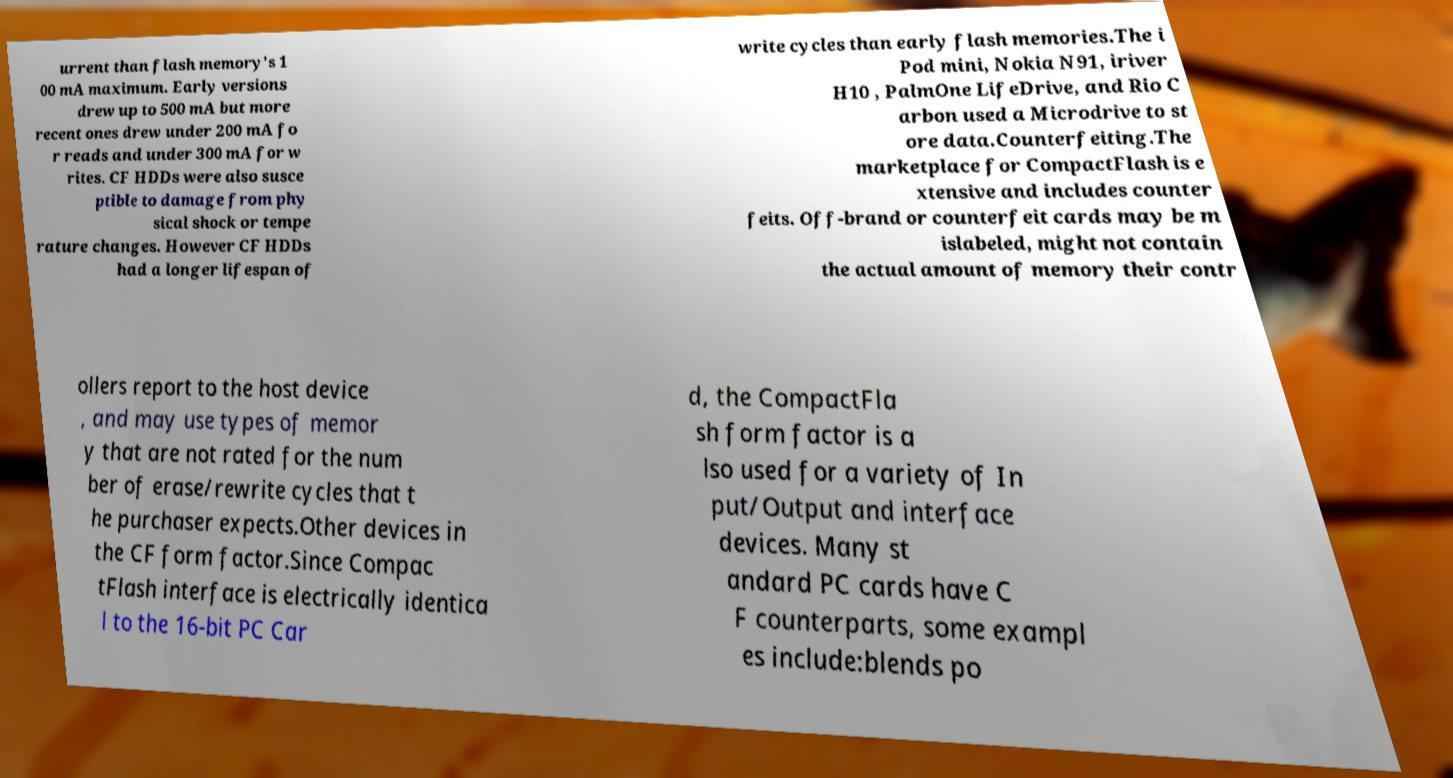Please identify and transcribe the text found in this image. urrent than flash memory's 1 00 mA maximum. Early versions drew up to 500 mA but more recent ones drew under 200 mA fo r reads and under 300 mA for w rites. CF HDDs were also susce ptible to damage from phy sical shock or tempe rature changes. However CF HDDs had a longer lifespan of write cycles than early flash memories.The i Pod mini, Nokia N91, iriver H10 , PalmOne LifeDrive, and Rio C arbon used a Microdrive to st ore data.Counterfeiting.The marketplace for CompactFlash is e xtensive and includes counter feits. Off-brand or counterfeit cards may be m islabeled, might not contain the actual amount of memory their contr ollers report to the host device , and may use types of memor y that are not rated for the num ber of erase/rewrite cycles that t he purchaser expects.Other devices in the CF form factor.Since Compac tFlash interface is electrically identica l to the 16-bit PC Car d, the CompactFla sh form factor is a lso used for a variety of In put/Output and interface devices. Many st andard PC cards have C F counterparts, some exampl es include:blends po 